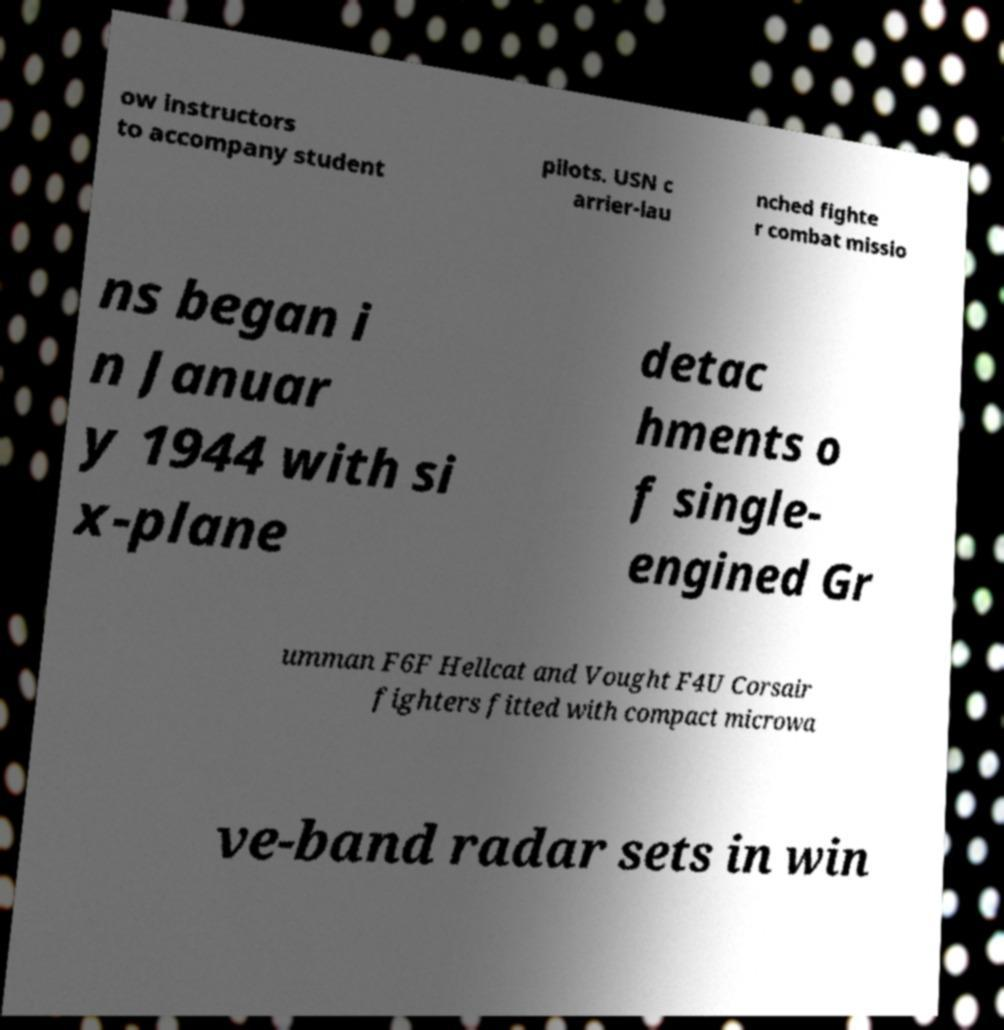Can you accurately transcribe the text from the provided image for me? ow instructors to accompany student pilots. USN c arrier-lau nched fighte r combat missio ns began i n Januar y 1944 with si x-plane detac hments o f single- engined Gr umman F6F Hellcat and Vought F4U Corsair fighters fitted with compact microwa ve-band radar sets in win 